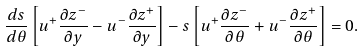<formula> <loc_0><loc_0><loc_500><loc_500>\frac { d s } { d \theta } \left [ u ^ { + } \frac { \partial z ^ { - } } { \partial y } - u ^ { - } \frac { \partial z ^ { + } } { \partial y } \right ] - s \left [ u ^ { + } \frac { \partial z ^ { - } } { \partial \theta } + u ^ { - } \frac { \partial z ^ { + } } { \partial \theta } \right ] = 0 .</formula> 